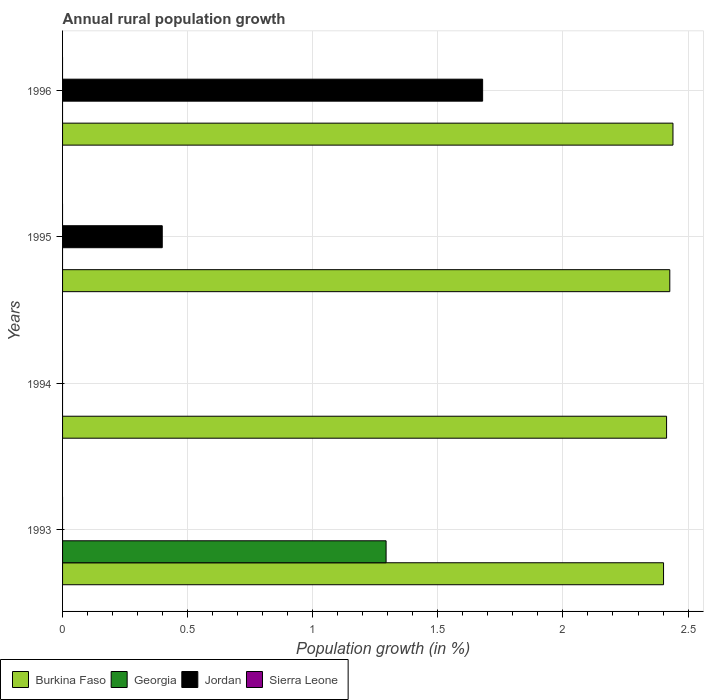Are the number of bars per tick equal to the number of legend labels?
Provide a succinct answer. No. How many bars are there on the 3rd tick from the top?
Offer a very short reply. 1. How many bars are there on the 1st tick from the bottom?
Ensure brevity in your answer.  2. What is the label of the 4th group of bars from the top?
Provide a short and direct response. 1993. In how many cases, is the number of bars for a given year not equal to the number of legend labels?
Ensure brevity in your answer.  4. Across all years, what is the maximum percentage of rural population growth in Jordan?
Your answer should be very brief. 1.68. Across all years, what is the minimum percentage of rural population growth in Sierra Leone?
Give a very brief answer. 0. What is the difference between the percentage of rural population growth in Burkina Faso in 1994 and that in 1996?
Ensure brevity in your answer.  -0.03. What is the difference between the percentage of rural population growth in Georgia in 1993 and the percentage of rural population growth in Sierra Leone in 1996?
Ensure brevity in your answer.  1.29. What is the average percentage of rural population growth in Georgia per year?
Keep it short and to the point. 0.32. In the year 1993, what is the difference between the percentage of rural population growth in Burkina Faso and percentage of rural population growth in Georgia?
Give a very brief answer. 1.11. In how many years, is the percentage of rural population growth in Sierra Leone greater than 0.2 %?
Ensure brevity in your answer.  0. What is the ratio of the percentage of rural population growth in Jordan in 1995 to that in 1996?
Offer a terse response. 0.24. What is the difference between the highest and the lowest percentage of rural population growth in Jordan?
Offer a terse response. 1.68. In how many years, is the percentage of rural population growth in Georgia greater than the average percentage of rural population growth in Georgia taken over all years?
Make the answer very short. 1. Is it the case that in every year, the sum of the percentage of rural population growth in Georgia and percentage of rural population growth in Jordan is greater than the percentage of rural population growth in Sierra Leone?
Offer a terse response. No. What is the difference between two consecutive major ticks on the X-axis?
Offer a terse response. 0.5. Are the values on the major ticks of X-axis written in scientific E-notation?
Provide a succinct answer. No. How many legend labels are there?
Provide a short and direct response. 4. What is the title of the graph?
Ensure brevity in your answer.  Annual rural population growth. Does "New Caledonia" appear as one of the legend labels in the graph?
Your answer should be very brief. No. What is the label or title of the X-axis?
Make the answer very short. Population growth (in %). What is the Population growth (in %) of Burkina Faso in 1993?
Offer a very short reply. 2.4. What is the Population growth (in %) in Georgia in 1993?
Your response must be concise. 1.29. What is the Population growth (in %) of Burkina Faso in 1994?
Your response must be concise. 2.41. What is the Population growth (in %) of Georgia in 1994?
Your answer should be very brief. 0. What is the Population growth (in %) in Sierra Leone in 1994?
Your response must be concise. 0. What is the Population growth (in %) of Burkina Faso in 1995?
Keep it short and to the point. 2.43. What is the Population growth (in %) of Jordan in 1995?
Offer a very short reply. 0.4. What is the Population growth (in %) of Sierra Leone in 1995?
Offer a very short reply. 0. What is the Population growth (in %) of Burkina Faso in 1996?
Ensure brevity in your answer.  2.44. What is the Population growth (in %) in Jordan in 1996?
Ensure brevity in your answer.  1.68. What is the Population growth (in %) of Sierra Leone in 1996?
Your answer should be compact. 0. Across all years, what is the maximum Population growth (in %) in Burkina Faso?
Give a very brief answer. 2.44. Across all years, what is the maximum Population growth (in %) of Georgia?
Your answer should be very brief. 1.29. Across all years, what is the maximum Population growth (in %) in Jordan?
Provide a succinct answer. 1.68. Across all years, what is the minimum Population growth (in %) in Burkina Faso?
Your answer should be compact. 2.4. Across all years, what is the minimum Population growth (in %) of Georgia?
Make the answer very short. 0. Across all years, what is the minimum Population growth (in %) in Jordan?
Your response must be concise. 0. What is the total Population growth (in %) in Burkina Faso in the graph?
Your response must be concise. 9.68. What is the total Population growth (in %) in Georgia in the graph?
Give a very brief answer. 1.29. What is the total Population growth (in %) in Jordan in the graph?
Ensure brevity in your answer.  2.08. What is the total Population growth (in %) in Sierra Leone in the graph?
Offer a very short reply. 0. What is the difference between the Population growth (in %) in Burkina Faso in 1993 and that in 1994?
Your answer should be compact. -0.01. What is the difference between the Population growth (in %) of Burkina Faso in 1993 and that in 1995?
Keep it short and to the point. -0.03. What is the difference between the Population growth (in %) of Burkina Faso in 1993 and that in 1996?
Provide a succinct answer. -0.04. What is the difference between the Population growth (in %) of Burkina Faso in 1994 and that in 1995?
Make the answer very short. -0.01. What is the difference between the Population growth (in %) of Burkina Faso in 1994 and that in 1996?
Your answer should be compact. -0.03. What is the difference between the Population growth (in %) of Burkina Faso in 1995 and that in 1996?
Make the answer very short. -0.01. What is the difference between the Population growth (in %) of Jordan in 1995 and that in 1996?
Give a very brief answer. -1.28. What is the difference between the Population growth (in %) in Burkina Faso in 1993 and the Population growth (in %) in Jordan in 1995?
Give a very brief answer. 2. What is the difference between the Population growth (in %) of Georgia in 1993 and the Population growth (in %) of Jordan in 1995?
Make the answer very short. 0.89. What is the difference between the Population growth (in %) of Burkina Faso in 1993 and the Population growth (in %) of Jordan in 1996?
Your answer should be compact. 0.72. What is the difference between the Population growth (in %) of Georgia in 1993 and the Population growth (in %) of Jordan in 1996?
Provide a short and direct response. -0.39. What is the difference between the Population growth (in %) in Burkina Faso in 1994 and the Population growth (in %) in Jordan in 1995?
Keep it short and to the point. 2.02. What is the difference between the Population growth (in %) in Burkina Faso in 1994 and the Population growth (in %) in Jordan in 1996?
Ensure brevity in your answer.  0.74. What is the difference between the Population growth (in %) of Burkina Faso in 1995 and the Population growth (in %) of Jordan in 1996?
Make the answer very short. 0.75. What is the average Population growth (in %) of Burkina Faso per year?
Provide a succinct answer. 2.42. What is the average Population growth (in %) in Georgia per year?
Your answer should be very brief. 0.32. What is the average Population growth (in %) of Jordan per year?
Offer a very short reply. 0.52. In the year 1993, what is the difference between the Population growth (in %) in Burkina Faso and Population growth (in %) in Georgia?
Your answer should be very brief. 1.11. In the year 1995, what is the difference between the Population growth (in %) of Burkina Faso and Population growth (in %) of Jordan?
Make the answer very short. 2.03. In the year 1996, what is the difference between the Population growth (in %) of Burkina Faso and Population growth (in %) of Jordan?
Keep it short and to the point. 0.76. What is the ratio of the Population growth (in %) in Burkina Faso in 1993 to that in 1994?
Your response must be concise. 0.99. What is the ratio of the Population growth (in %) in Burkina Faso in 1993 to that in 1995?
Your answer should be compact. 0.99. What is the ratio of the Population growth (in %) of Burkina Faso in 1993 to that in 1996?
Provide a succinct answer. 0.98. What is the ratio of the Population growth (in %) of Burkina Faso in 1994 to that in 1995?
Offer a very short reply. 0.99. What is the ratio of the Population growth (in %) of Burkina Faso in 1995 to that in 1996?
Provide a succinct answer. 0.99. What is the ratio of the Population growth (in %) of Jordan in 1995 to that in 1996?
Make the answer very short. 0.24. What is the difference between the highest and the second highest Population growth (in %) of Burkina Faso?
Your response must be concise. 0.01. What is the difference between the highest and the lowest Population growth (in %) of Burkina Faso?
Make the answer very short. 0.04. What is the difference between the highest and the lowest Population growth (in %) in Georgia?
Your answer should be compact. 1.29. What is the difference between the highest and the lowest Population growth (in %) in Jordan?
Your response must be concise. 1.68. 